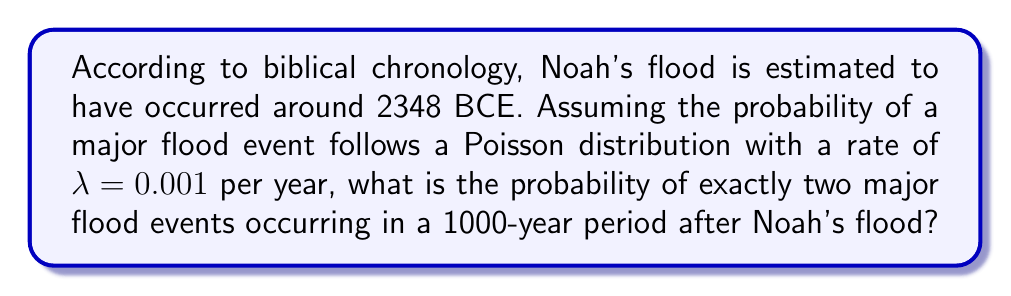Help me with this question. To solve this problem, we'll use the Poisson distribution formula:

$$P(X = k) = \frac{e^{-\lambda} \lambda^k}{k!}$$

Where:
- $\lambda$ is the average rate of events per time period
- $k$ is the number of events we're calculating the probability for
- $e$ is Euler's number (approximately 2.71828)

Given:
- $\lambda = 0.001$ per year
- Time period = 1000 years
- $k = 2$ (exactly two events)

Step 1: Calculate $\lambda$ for the 1000-year period:
$\lambda_{1000} = 0.001 \times 1000 = 1$

Step 2: Apply the Poisson distribution formula:

$$P(X = 2) = \frac{e^{-1} 1^2}{2!}$$

Step 3: Simplify:
$$P(X = 2) = \frac{e^{-1} \times 1}{2}$$

Step 4: Calculate the final probability:
$$P(X = 2) = \frac{0.36788}{2} = 0.18394$$
Answer: $0.18394$ or approximately $18.39\%$ 